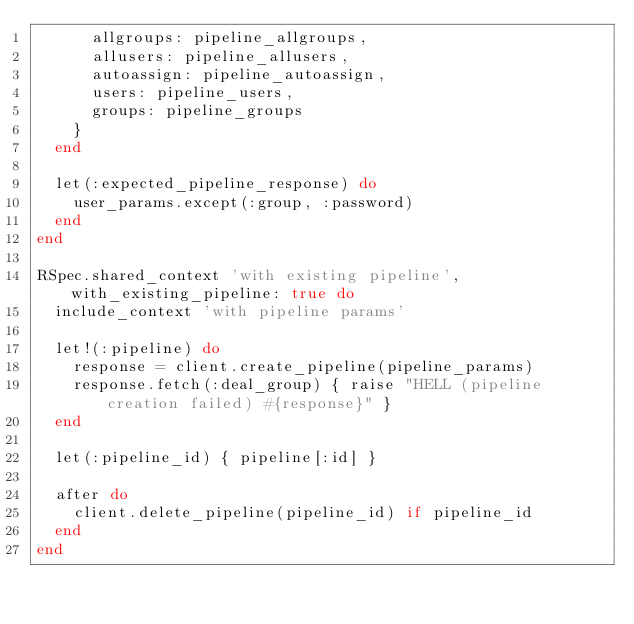Convert code to text. <code><loc_0><loc_0><loc_500><loc_500><_Ruby_>      allgroups: pipeline_allgroups,
      allusers: pipeline_allusers,
      autoassign: pipeline_autoassign,
      users: pipeline_users,
      groups: pipeline_groups
    }
  end

  let(:expected_pipeline_response) do
    user_params.except(:group, :password)
  end
end

RSpec.shared_context 'with existing pipeline', with_existing_pipeline: true do
  include_context 'with pipeline params'

  let!(:pipeline) do
    response = client.create_pipeline(pipeline_params)
    response.fetch(:deal_group) { raise "HELL (pipeline creation failed) #{response}" }
  end

  let(:pipeline_id) { pipeline[:id] }

  after do
    client.delete_pipeline(pipeline_id) if pipeline_id
  end
end
</code> 